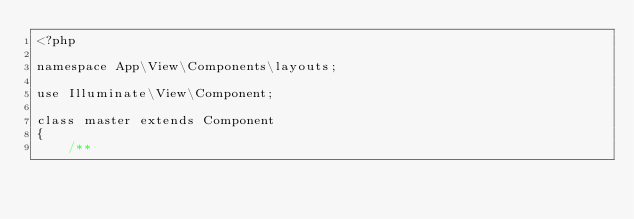Convert code to text. <code><loc_0><loc_0><loc_500><loc_500><_PHP_><?php

namespace App\View\Components\layouts;

use Illuminate\View\Component;

class master extends Component
{
    /**</code> 